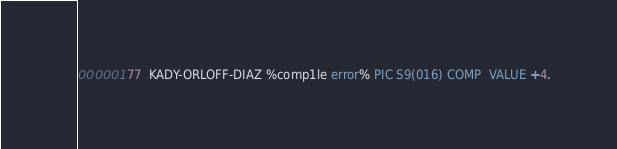<code> <loc_0><loc_0><loc_500><loc_500><_COBOL_>000001 77  KADY-ORLOFF-DIAZ %comp1le error% PIC S9(016) COMP  VALUE +4.
</code> 